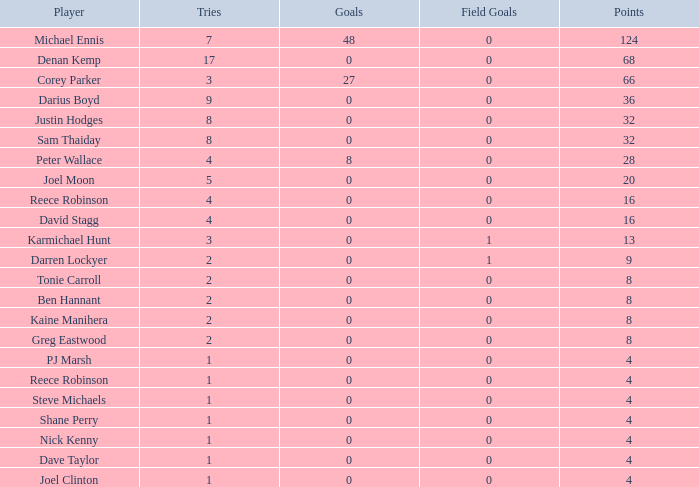What is the goal count for dave taylor, who has achieved more than a single try? None. 